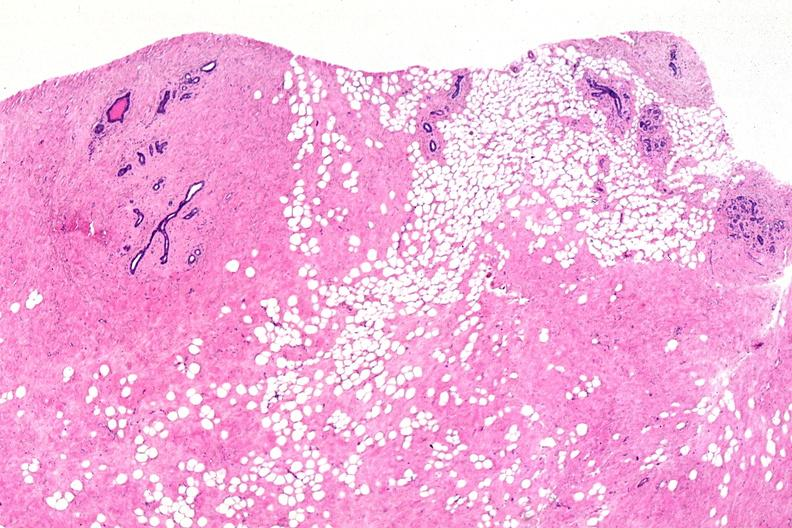does this image show normal breast?
Answer the question using a single word or phrase. Yes 